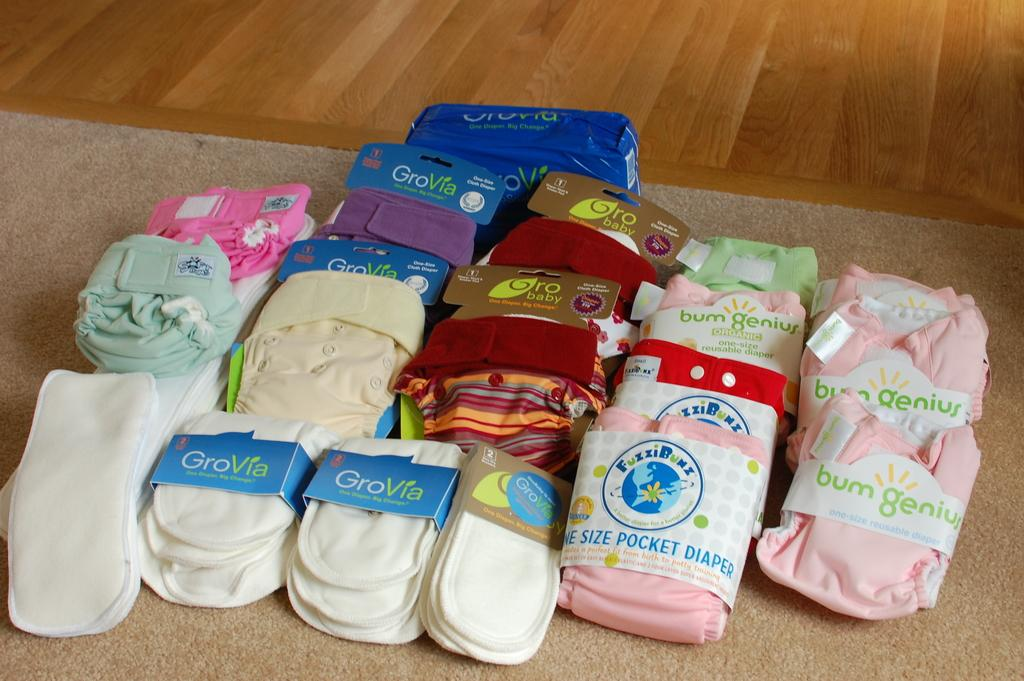What type of product is featured in the center of the image? There are diapers in the center of the image. Can you describe the location of the diapers in the image? The diapers are in the center of the image. What type of flooring is visible in the image? There is a rug in the image. What shape is the family's uncle in the image? There is no family or uncle present in the image; it only features diapers and a rug. 